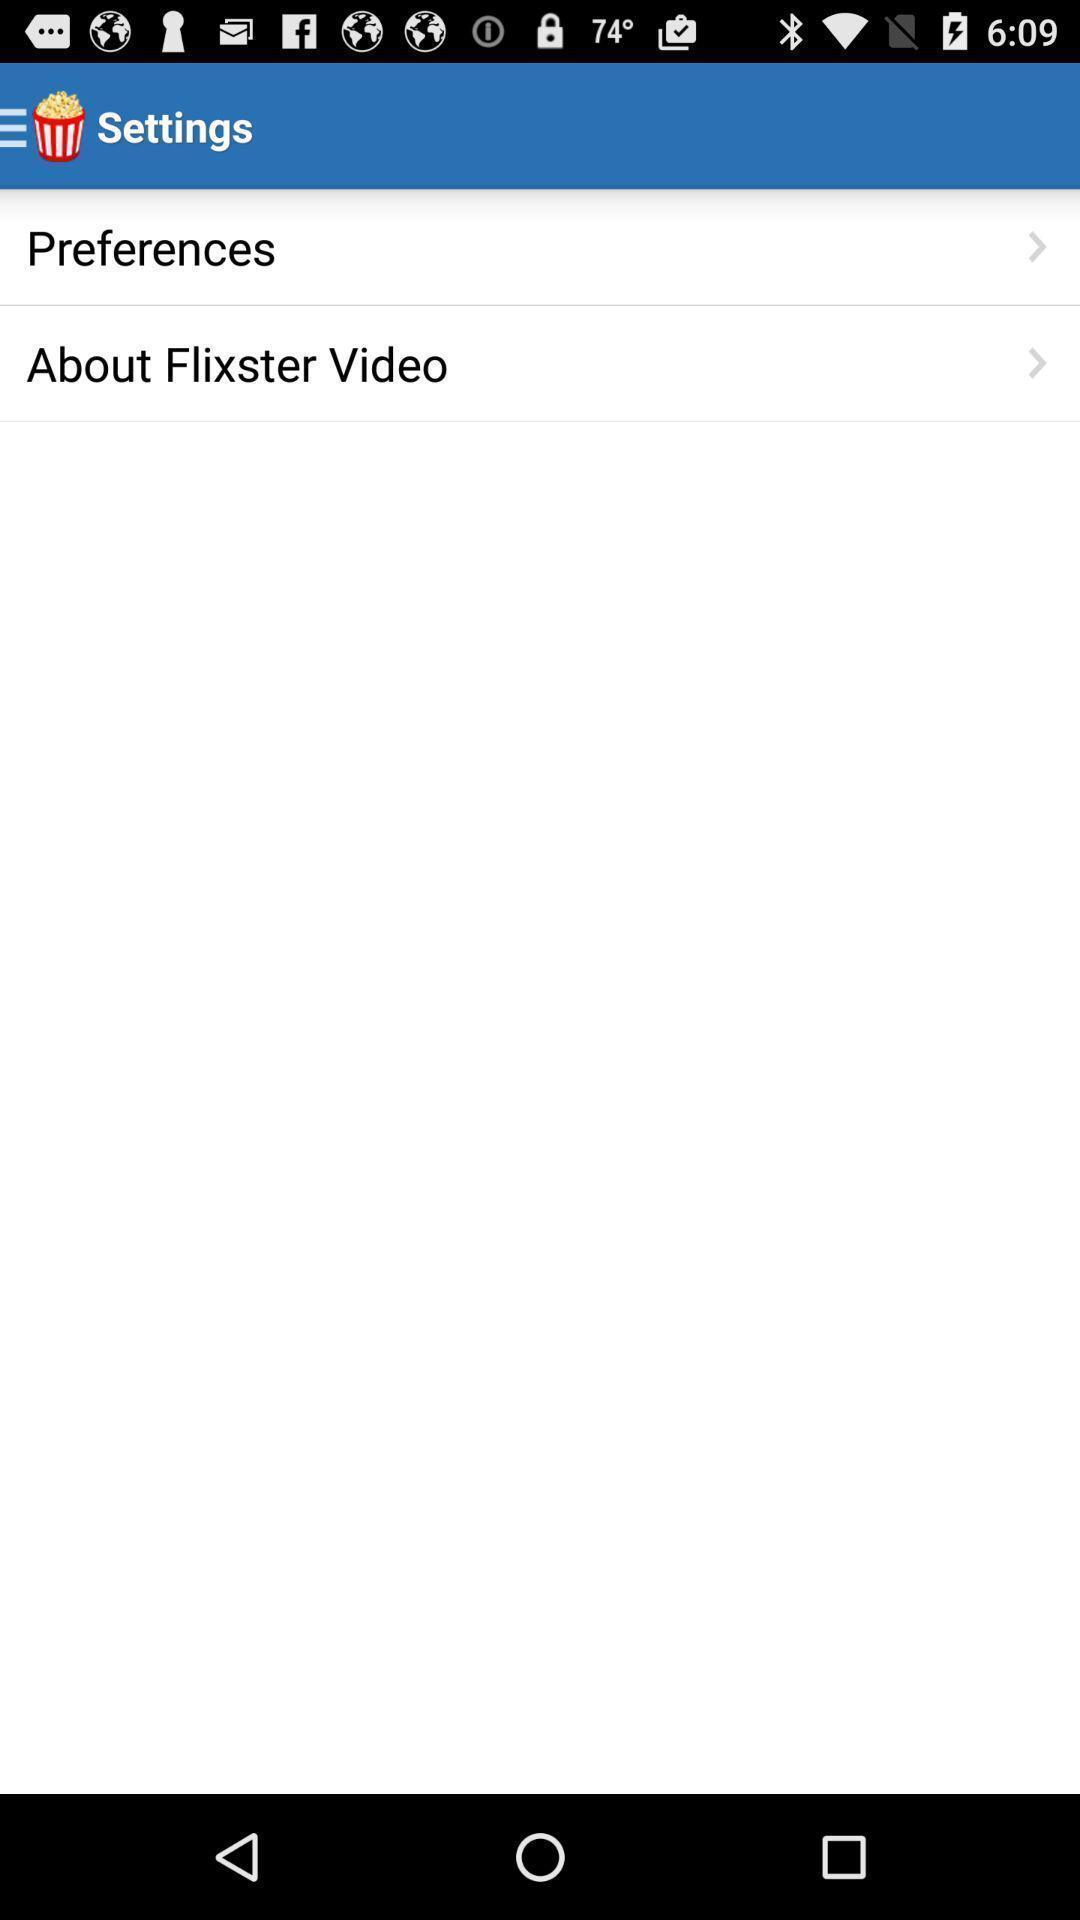What is the overall content of this screenshot? Two settings are showing in the page. 